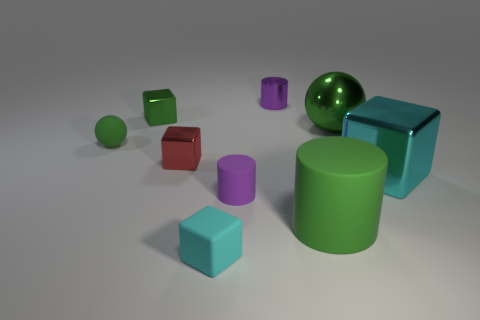Are there any other things that have the same size as the red object?
Give a very brief answer. Yes. There is a small purple object that is in front of the purple thing that is behind the small ball; what is it made of?
Ensure brevity in your answer.  Rubber. Does the cyan metallic object have the same size as the purple metal thing?
Your response must be concise. No. How many things are either purple shiny cylinders to the right of the small red block or big red metal cylinders?
Provide a succinct answer. 1. The cyan thing that is in front of the large green thing left of the green metallic ball is what shape?
Provide a succinct answer. Cube. Does the purple rubber cylinder have the same size as the cyan cube that is right of the cyan rubber cube?
Offer a terse response. No. What material is the cyan object that is on the left side of the tiny matte cylinder?
Make the answer very short. Rubber. What number of cyan objects are right of the purple metal thing and left of the purple matte cylinder?
Make the answer very short. 0. What is the material of the purple cylinder that is the same size as the purple rubber thing?
Your answer should be very brief. Metal. Do the green rubber thing behind the small red metallic thing and the sphere behind the tiny green matte object have the same size?
Offer a very short reply. No. 